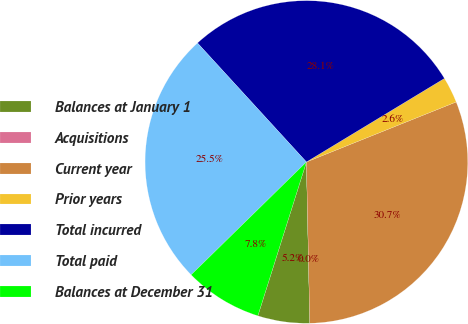Convert chart to OTSL. <chart><loc_0><loc_0><loc_500><loc_500><pie_chart><fcel>Balances at January 1<fcel>Acquisitions<fcel>Current year<fcel>Prior years<fcel>Total incurred<fcel>Total paid<fcel>Balances at December 31<nl><fcel>5.2%<fcel>0.0%<fcel>30.73%<fcel>2.6%<fcel>28.13%<fcel>25.53%<fcel>7.8%<nl></chart> 